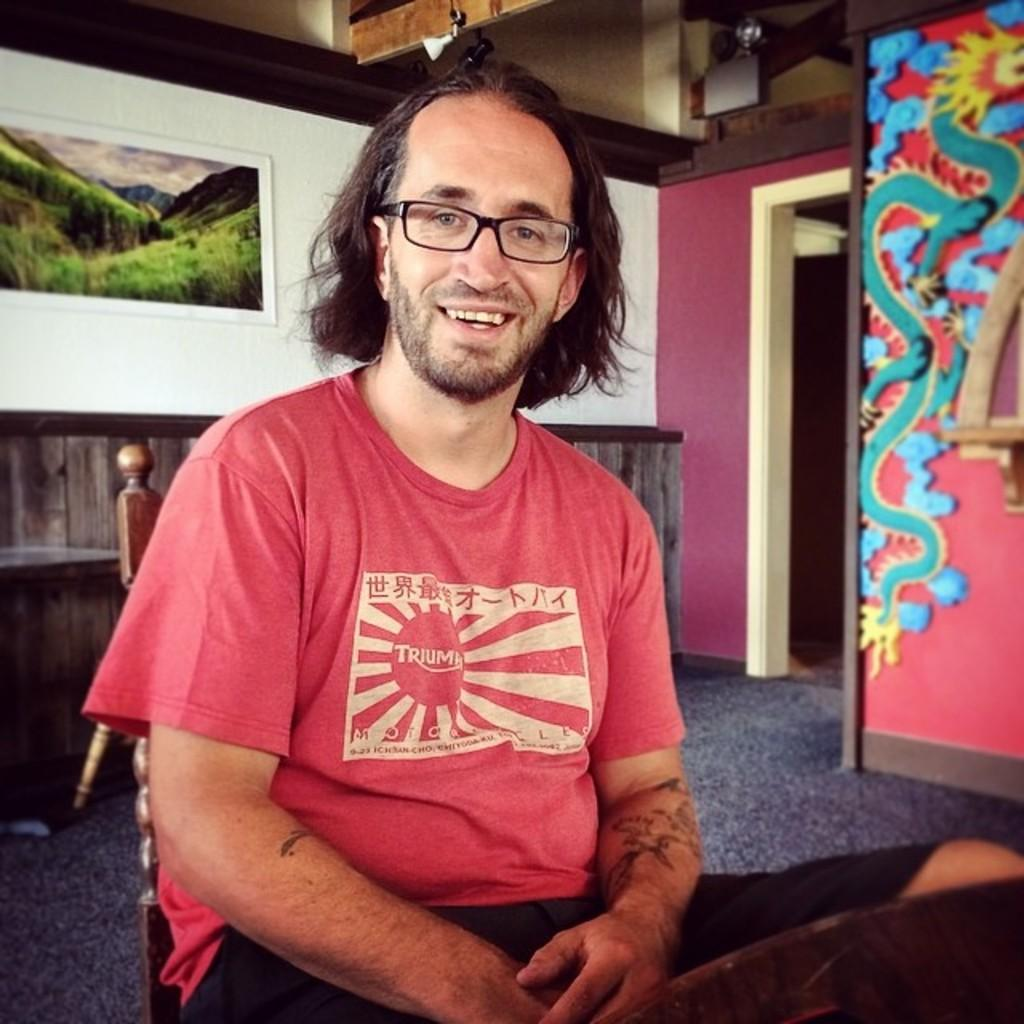What is the man in the image doing? The man is looking at something and smiling in the image. What can be seen on the man's face? The man is wearing glasses in the image. What type of clothing is the man wearing? The man is wearing a t-shirt in the image. What is the man's posture in the image? The man is sitting on a chair in the image. What is visible in the background of the image? There is a floor, a wall, and a photo frame visible in the background of the image. What type of leaf is the man holding in the image? There is no leaf present in the image; the man is not holding anything. 